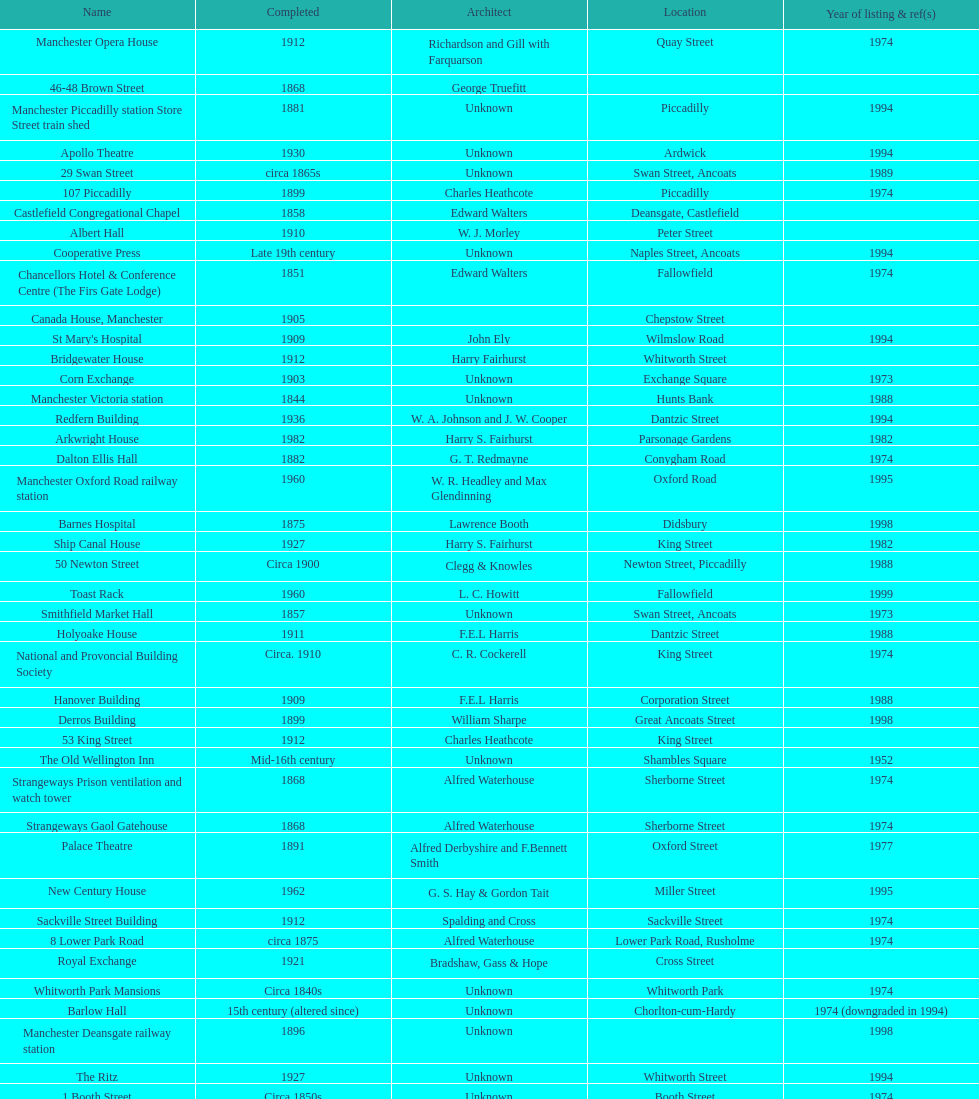Which two buildings were listed before 1974? The Old Wellington Inn, Smithfield Market Hall. 